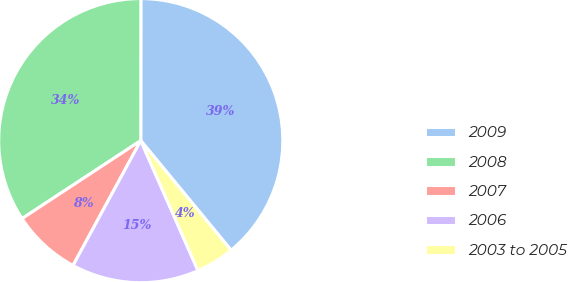Convert chart. <chart><loc_0><loc_0><loc_500><loc_500><pie_chart><fcel>2009<fcel>2008<fcel>2007<fcel>2006<fcel>2003 to 2005<nl><fcel>39.02%<fcel>34.26%<fcel>7.84%<fcel>14.52%<fcel>4.37%<nl></chart> 